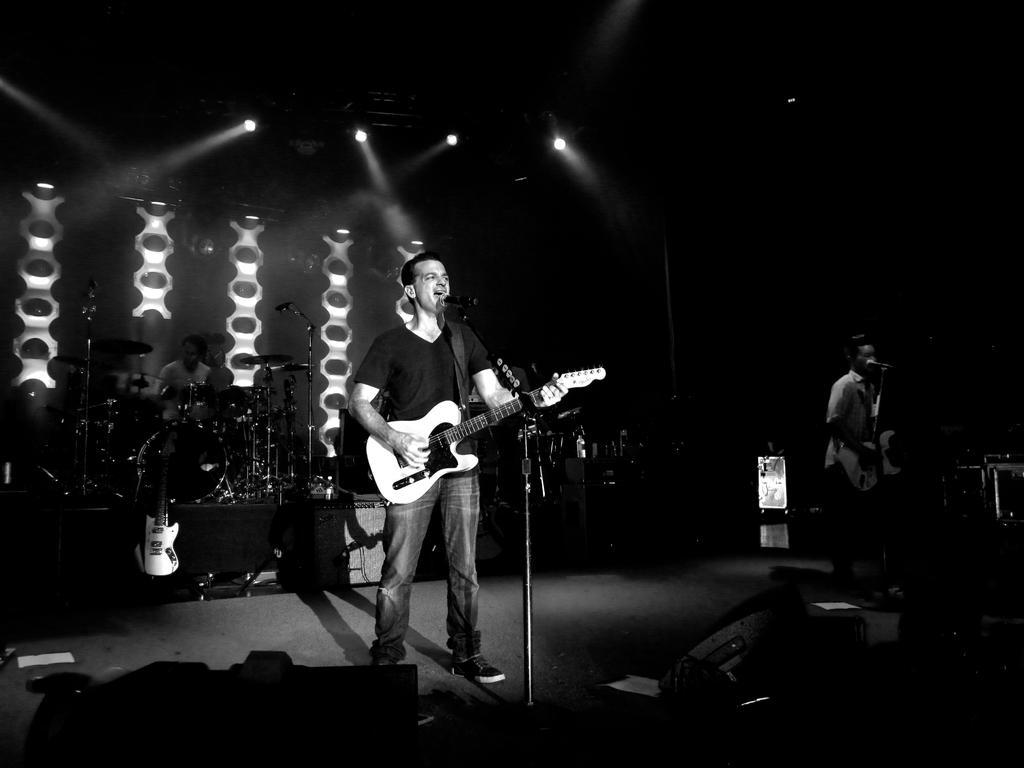How would you summarize this image in a sentence or two? In this image there are persons standing and performing on a stage holding musical instrument. In the background there is a musical instrument and there is a person sitting and playing the musical instrument and there are lights. In the front there are objects which are black and white in colour. 